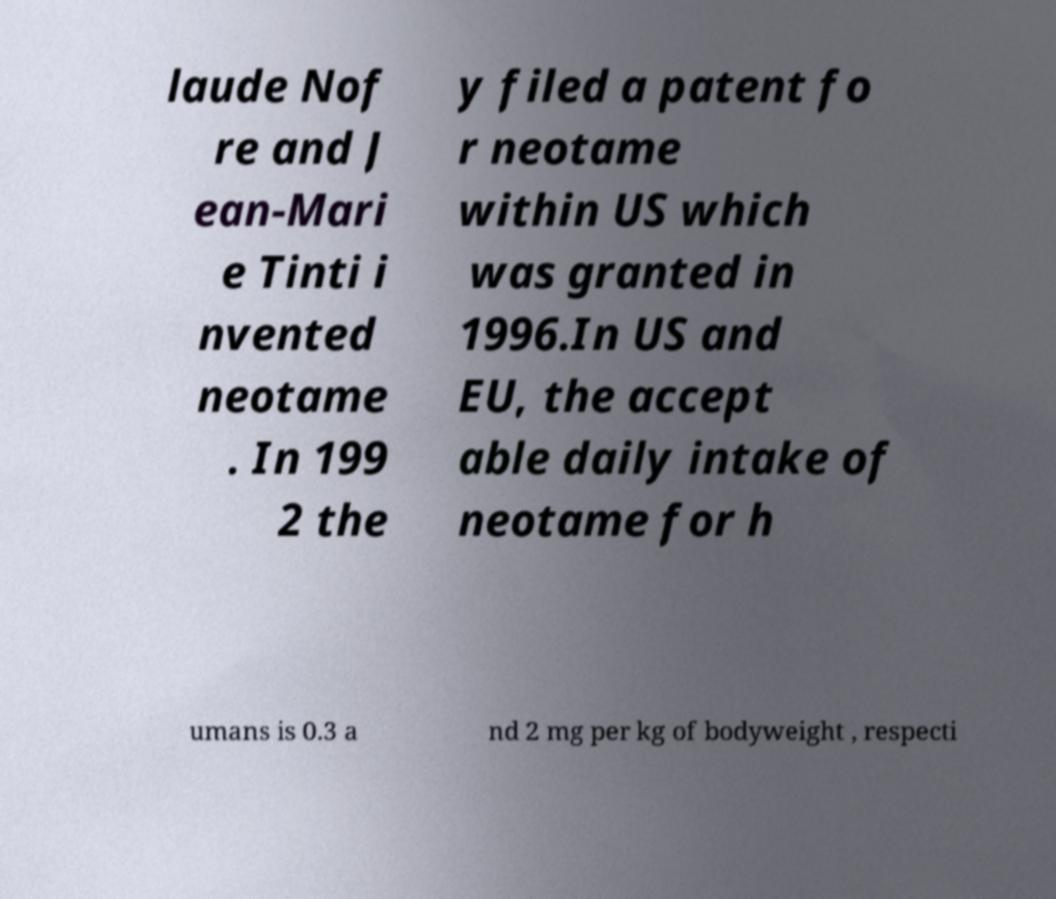Could you extract and type out the text from this image? laude Nof re and J ean-Mari e Tinti i nvented neotame . In 199 2 the y filed a patent fo r neotame within US which was granted in 1996.In US and EU, the accept able daily intake of neotame for h umans is 0.3 a nd 2 mg per kg of bodyweight , respecti 